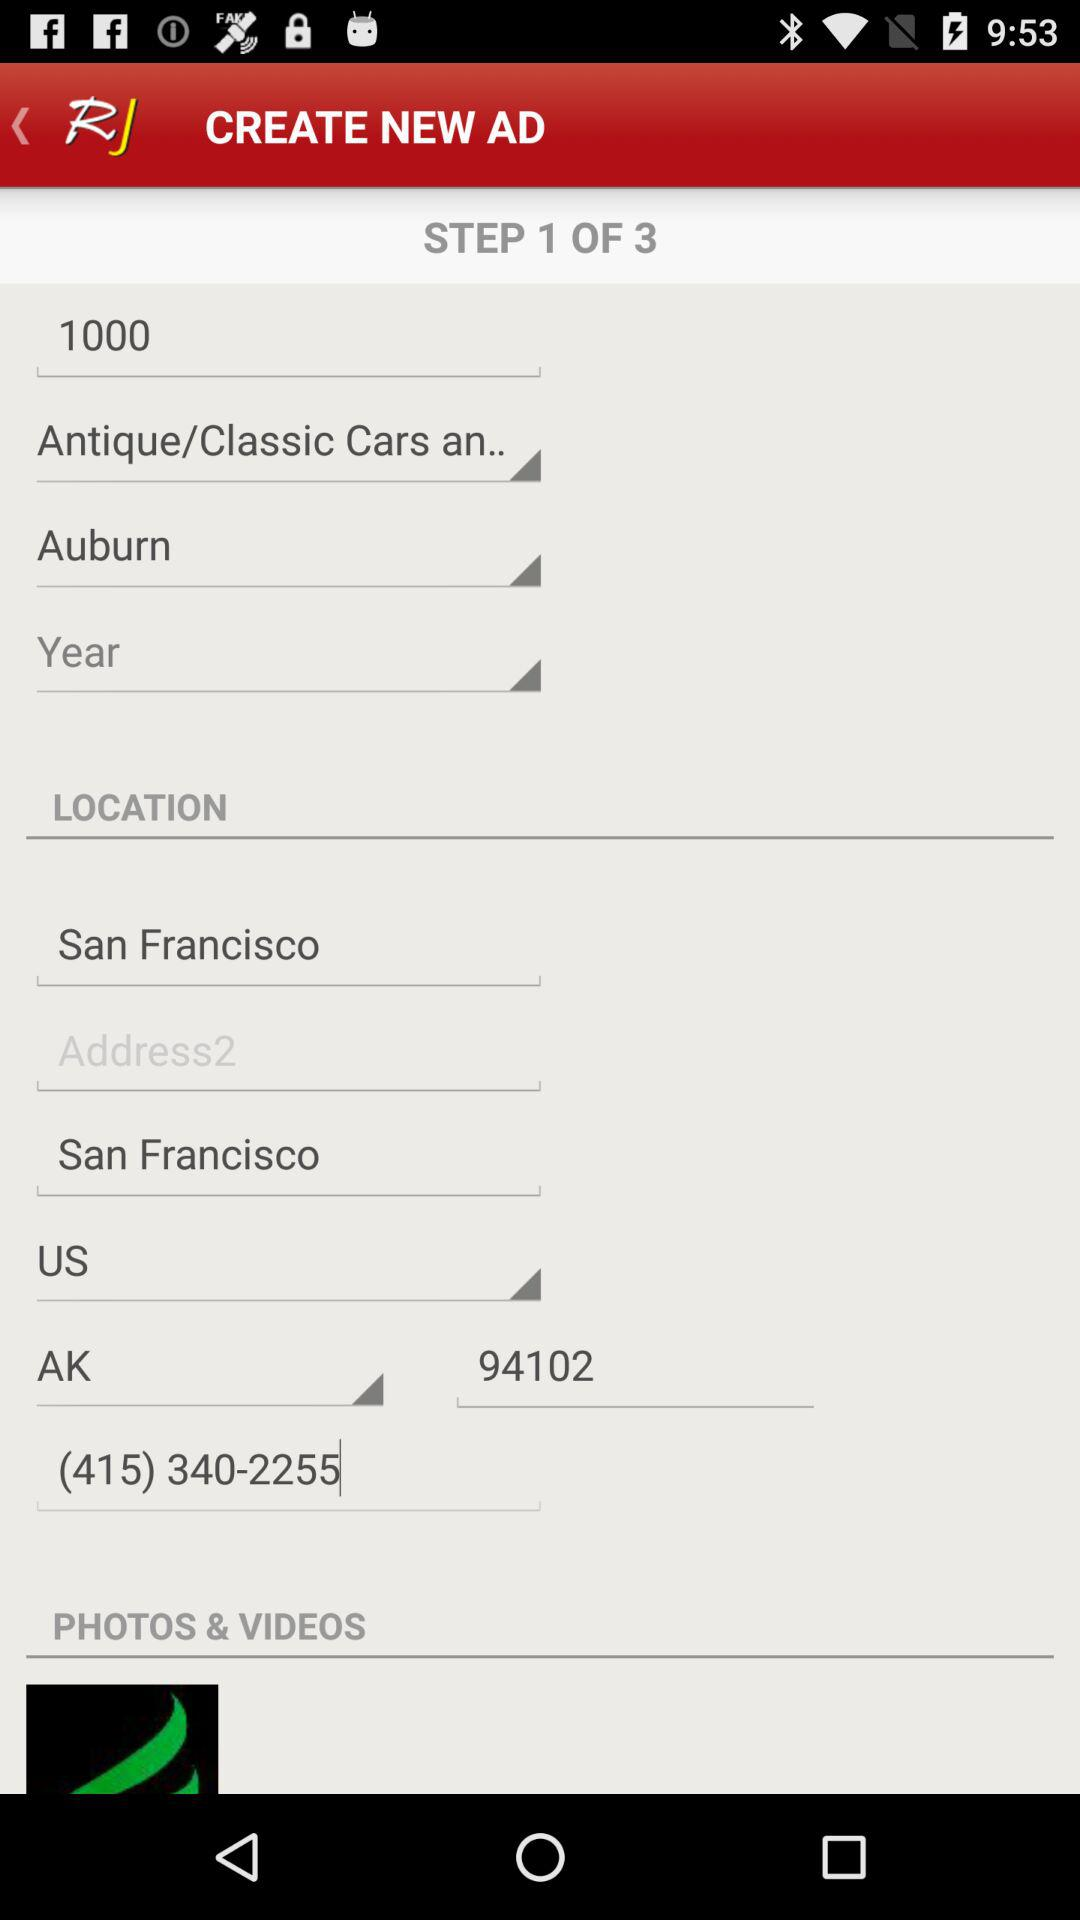Which types of cars are the ads being created for? The ads are being created for "Antique/Classic Cars an.." types of cars. 